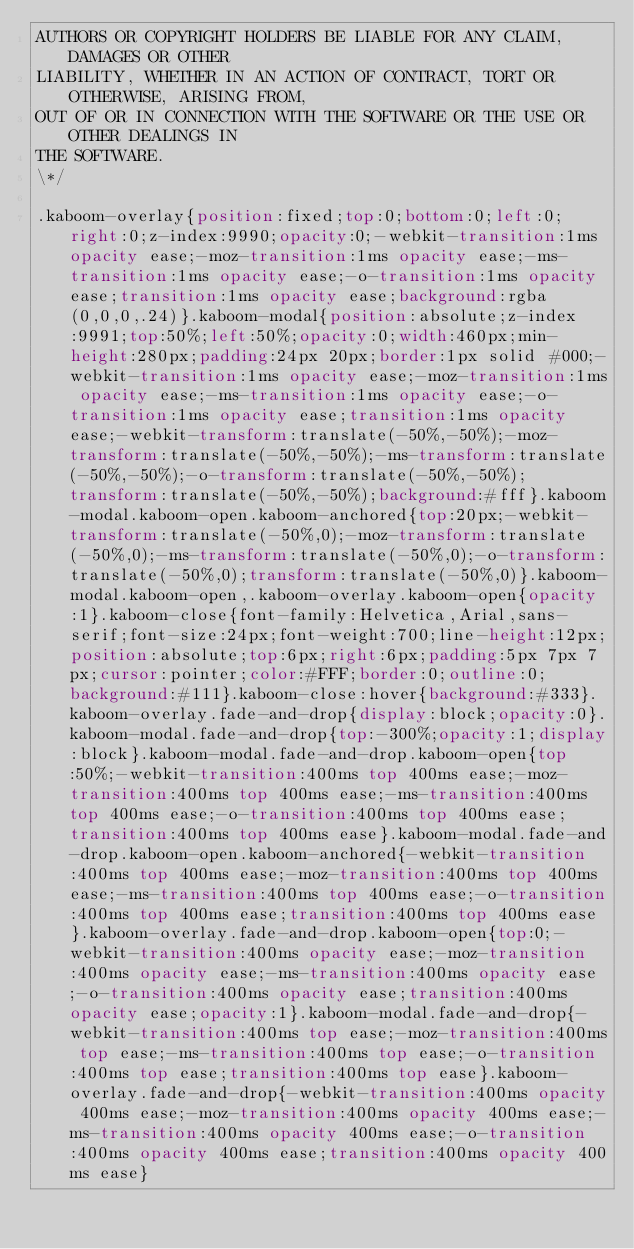<code> <loc_0><loc_0><loc_500><loc_500><_CSS_>AUTHORS OR COPYRIGHT HOLDERS BE LIABLE FOR ANY CLAIM, DAMAGES OR OTHER
LIABILITY, WHETHER IN AN ACTION OF CONTRACT, TORT OR OTHERWISE, ARISING FROM,
OUT OF OR IN CONNECTION WITH THE SOFTWARE OR THE USE OR OTHER DEALINGS IN
THE SOFTWARE.
\*/

.kaboom-overlay{position:fixed;top:0;bottom:0;left:0;right:0;z-index:9990;opacity:0;-webkit-transition:1ms opacity ease;-moz-transition:1ms opacity ease;-ms-transition:1ms opacity ease;-o-transition:1ms opacity ease;transition:1ms opacity ease;background:rgba(0,0,0,.24)}.kaboom-modal{position:absolute;z-index:9991;top:50%;left:50%;opacity:0;width:460px;min-height:280px;padding:24px 20px;border:1px solid #000;-webkit-transition:1ms opacity ease;-moz-transition:1ms opacity ease;-ms-transition:1ms opacity ease;-o-transition:1ms opacity ease;transition:1ms opacity ease;-webkit-transform:translate(-50%,-50%);-moz-transform:translate(-50%,-50%);-ms-transform:translate(-50%,-50%);-o-transform:translate(-50%,-50%);transform:translate(-50%,-50%);background:#fff}.kaboom-modal.kaboom-open.kaboom-anchored{top:20px;-webkit-transform:translate(-50%,0);-moz-transform:translate(-50%,0);-ms-transform:translate(-50%,0);-o-transform:translate(-50%,0);transform:translate(-50%,0)}.kaboom-modal.kaboom-open,.kaboom-overlay.kaboom-open{opacity:1}.kaboom-close{font-family:Helvetica,Arial,sans-serif;font-size:24px;font-weight:700;line-height:12px;position:absolute;top:6px;right:6px;padding:5px 7px 7px;cursor:pointer;color:#FFF;border:0;outline:0;background:#111}.kaboom-close:hover{background:#333}.kaboom-overlay.fade-and-drop{display:block;opacity:0}.kaboom-modal.fade-and-drop{top:-300%;opacity:1;display:block}.kaboom-modal.fade-and-drop.kaboom-open{top:50%;-webkit-transition:400ms top 400ms ease;-moz-transition:400ms top 400ms ease;-ms-transition:400ms top 400ms ease;-o-transition:400ms top 400ms ease;transition:400ms top 400ms ease}.kaboom-modal.fade-and-drop.kaboom-open.kaboom-anchored{-webkit-transition:400ms top 400ms ease;-moz-transition:400ms top 400ms ease;-ms-transition:400ms top 400ms ease;-o-transition:400ms top 400ms ease;transition:400ms top 400ms ease}.kaboom-overlay.fade-and-drop.kaboom-open{top:0;-webkit-transition:400ms opacity ease;-moz-transition:400ms opacity ease;-ms-transition:400ms opacity ease;-o-transition:400ms opacity ease;transition:400ms opacity ease;opacity:1}.kaboom-modal.fade-and-drop{-webkit-transition:400ms top ease;-moz-transition:400ms top ease;-ms-transition:400ms top ease;-o-transition:400ms top ease;transition:400ms top ease}.kaboom-overlay.fade-and-drop{-webkit-transition:400ms opacity 400ms ease;-moz-transition:400ms opacity 400ms ease;-ms-transition:400ms opacity 400ms ease;-o-transition:400ms opacity 400ms ease;transition:400ms opacity 400ms ease}
</code> 